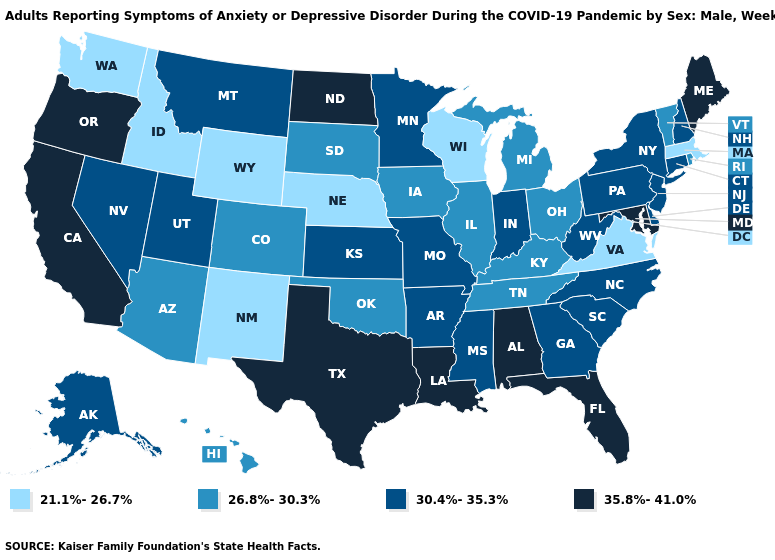Which states have the lowest value in the South?
Keep it brief. Virginia. What is the highest value in the South ?
Answer briefly. 35.8%-41.0%. Does Tennessee have a lower value than South Dakota?
Be succinct. No. What is the value of Kansas?
Give a very brief answer. 30.4%-35.3%. What is the value of Mississippi?
Quick response, please. 30.4%-35.3%. Name the states that have a value in the range 35.8%-41.0%?
Be succinct. Alabama, California, Florida, Louisiana, Maine, Maryland, North Dakota, Oregon, Texas. Does Hawaii have the lowest value in the West?
Write a very short answer. No. What is the value of Montana?
Keep it brief. 30.4%-35.3%. Does Nevada have a lower value than Alabama?
Answer briefly. Yes. What is the lowest value in states that border Tennessee?
Quick response, please. 21.1%-26.7%. Does California have a higher value than West Virginia?
Keep it brief. Yes. Does Pennsylvania have the lowest value in the USA?
Keep it brief. No. What is the value of Mississippi?
Give a very brief answer. 30.4%-35.3%. What is the value of Missouri?
Short answer required. 30.4%-35.3%. What is the highest value in states that border New York?
Keep it brief. 30.4%-35.3%. 